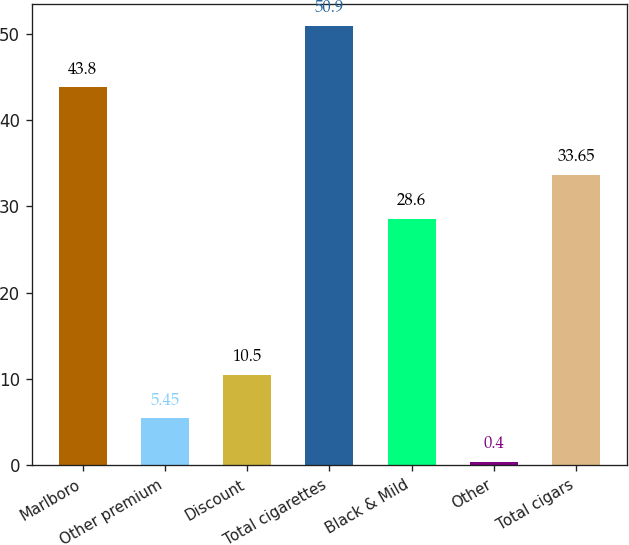<chart> <loc_0><loc_0><loc_500><loc_500><bar_chart><fcel>Marlboro<fcel>Other premium<fcel>Discount<fcel>Total cigarettes<fcel>Black & Mild<fcel>Other<fcel>Total cigars<nl><fcel>43.8<fcel>5.45<fcel>10.5<fcel>50.9<fcel>28.6<fcel>0.4<fcel>33.65<nl></chart> 